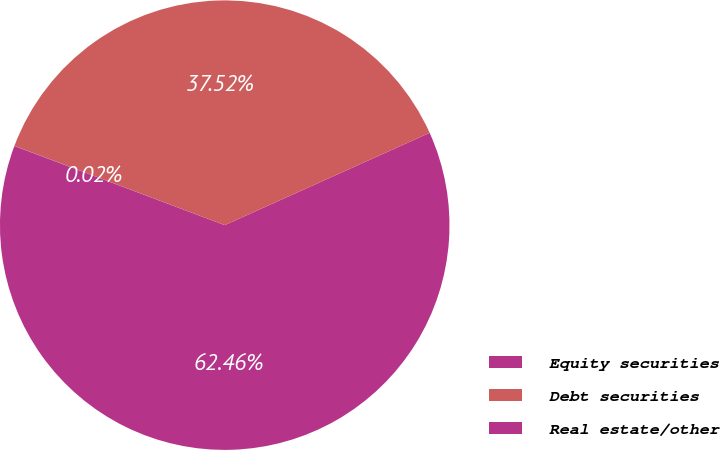Convert chart. <chart><loc_0><loc_0><loc_500><loc_500><pie_chart><fcel>Equity securities<fcel>Debt securities<fcel>Real estate/other<nl><fcel>62.46%<fcel>37.52%<fcel>0.02%<nl></chart> 